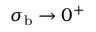<formula> <loc_0><loc_0><loc_500><loc_500>\sigma _ { b } \rightarrow 0 ^ { + }</formula> 